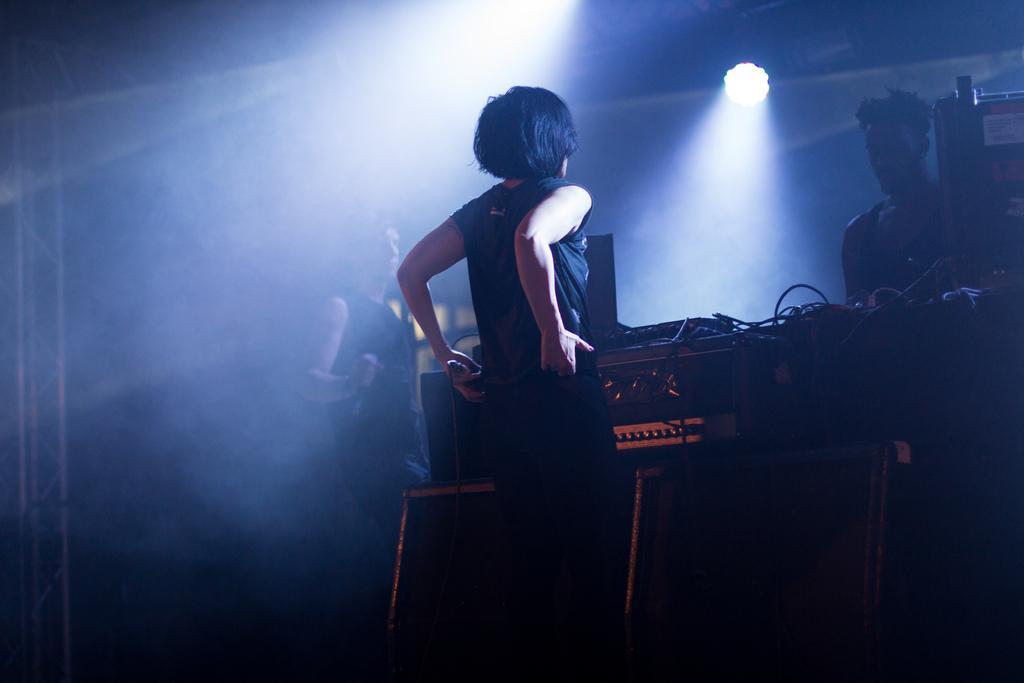Can you describe this image briefly? In this image I can see three persons are standing on the stage in front of a table on which I can see sound boxes, wires and so on. On the top I can see metal rods and lights. This image is taken on the stage. 